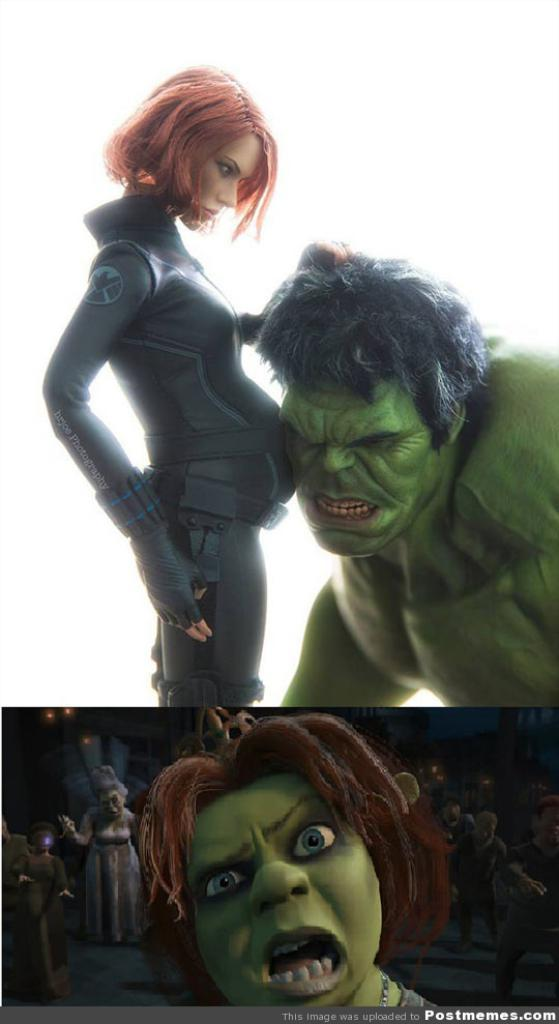What type of image is shown in the picture? The image appears to be a photo collage. What kind of pictures can be seen in the collage? There are animated pictures in the collage. Is there any text present in the image? Yes, there is text at the bottom of the image. What role does the zephyr play in the image? There is no zephyr present in the image, so it does not play any role. What type of material is used to create the lead in the image? There is no lead present in the image, so it is not possible to determine the material used. 